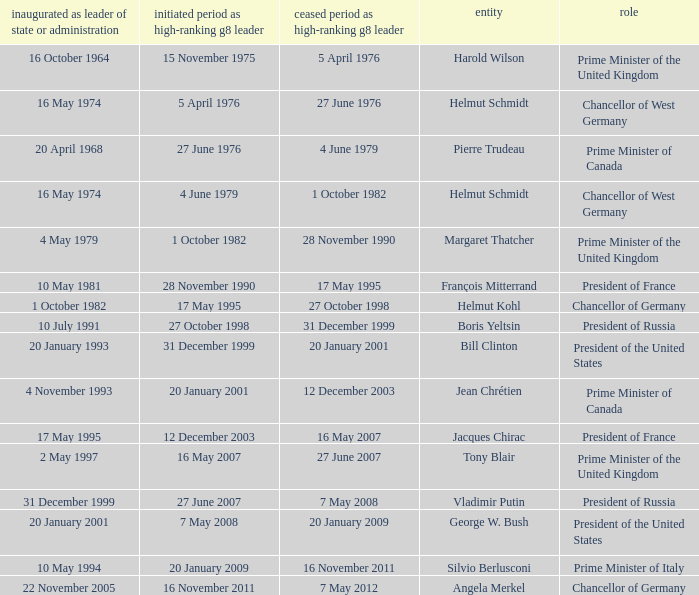When did Jacques Chirac stop being a G8 leader? 16 May 2007. 